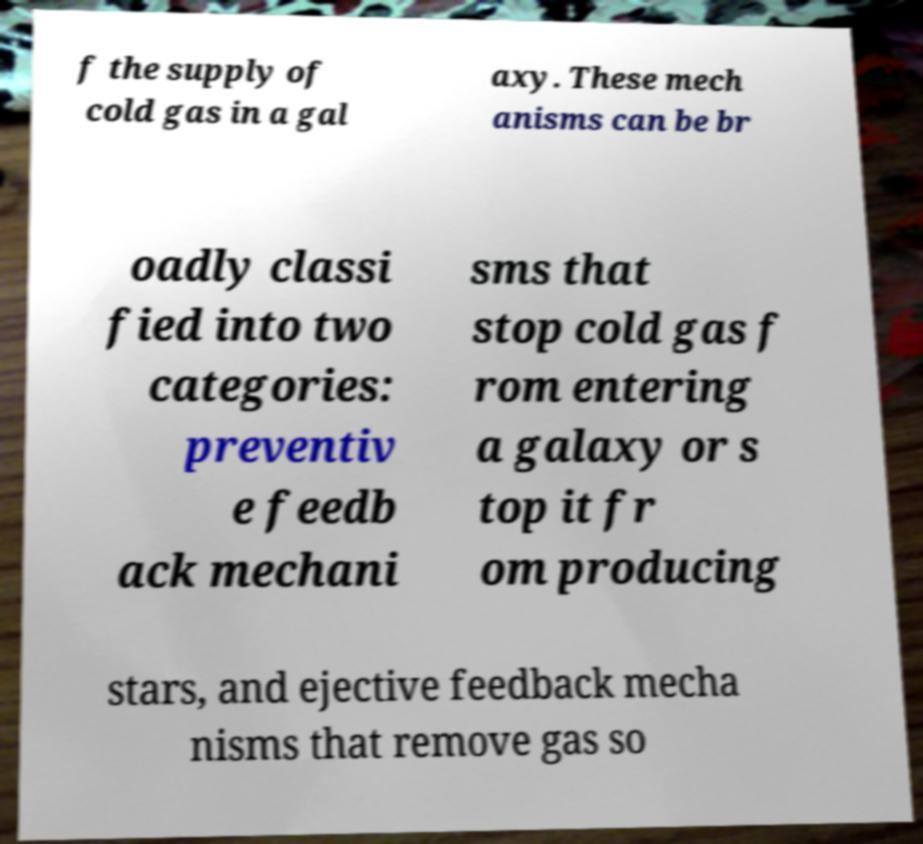What messages or text are displayed in this image? I need them in a readable, typed format. f the supply of cold gas in a gal axy. These mech anisms can be br oadly classi fied into two categories: preventiv e feedb ack mechani sms that stop cold gas f rom entering a galaxy or s top it fr om producing stars, and ejective feedback mecha nisms that remove gas so 